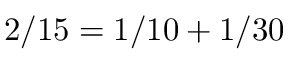Convert formula to latex. <formula><loc_0><loc_0><loc_500><loc_500>2 / 1 5 = 1 / 1 0 + 1 / 3 0</formula> 